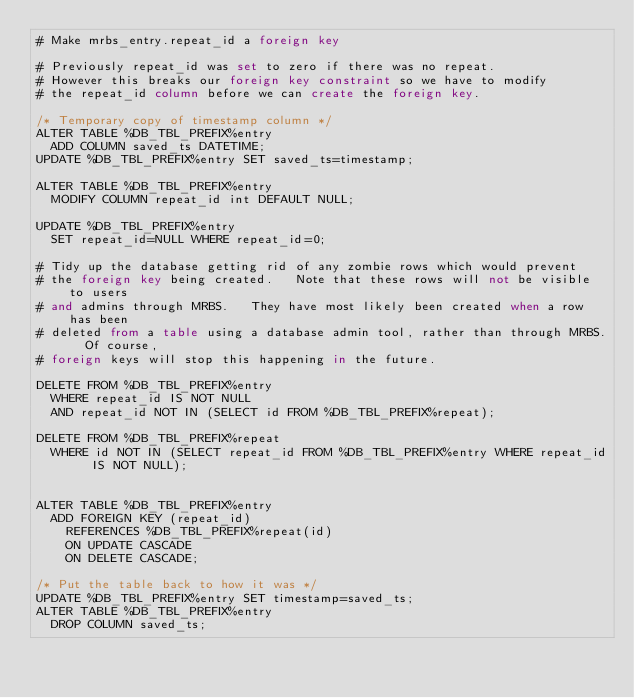Convert code to text. <code><loc_0><loc_0><loc_500><loc_500><_SQL_># Make mrbs_entry.repeat_id a foreign key

# Previously repeat_id was set to zero if there was no repeat.
# However this breaks our foreign key constraint so we have to modify
# the repeat_id column before we can create the foreign key.

/* Temporary copy of timestamp column */
ALTER TABLE %DB_TBL_PREFIX%entry
  ADD COLUMN saved_ts DATETIME;
UPDATE %DB_TBL_PREFIX%entry SET saved_ts=timestamp;

ALTER TABLE %DB_TBL_PREFIX%entry
  MODIFY COLUMN repeat_id int DEFAULT NULL;
  
UPDATE %DB_TBL_PREFIX%entry
  SET repeat_id=NULL WHERE repeat_id=0;

# Tidy up the database getting rid of any zombie rows which would prevent
# the foreign key being created.   Note that these rows will not be visible to users 
# and admins through MRBS.   They have most likely been created when a row has been
# deleted from a table using a database admin tool, rather than through MRBS.  Of course,
# foreign keys will stop this happening in the future.

DELETE FROM %DB_TBL_PREFIX%entry
  WHERE repeat_id IS NOT NULL
  AND repeat_id NOT IN (SELECT id FROM %DB_TBL_PREFIX%repeat);
  
DELETE FROM %DB_TBL_PREFIX%repeat
  WHERE id NOT IN (SELECT repeat_id FROM %DB_TBL_PREFIX%entry WHERE repeat_id IS NOT NULL);


ALTER TABLE %DB_TBL_PREFIX%entry
  ADD FOREIGN KEY (repeat_id) 
    REFERENCES %DB_TBL_PREFIX%repeat(id)
    ON UPDATE CASCADE
    ON DELETE CASCADE;

/* Put the table back to how it was */
UPDATE %DB_TBL_PREFIX%entry SET timestamp=saved_ts;
ALTER TABLE %DB_TBL_PREFIX%entry
  DROP COLUMN saved_ts;
</code> 